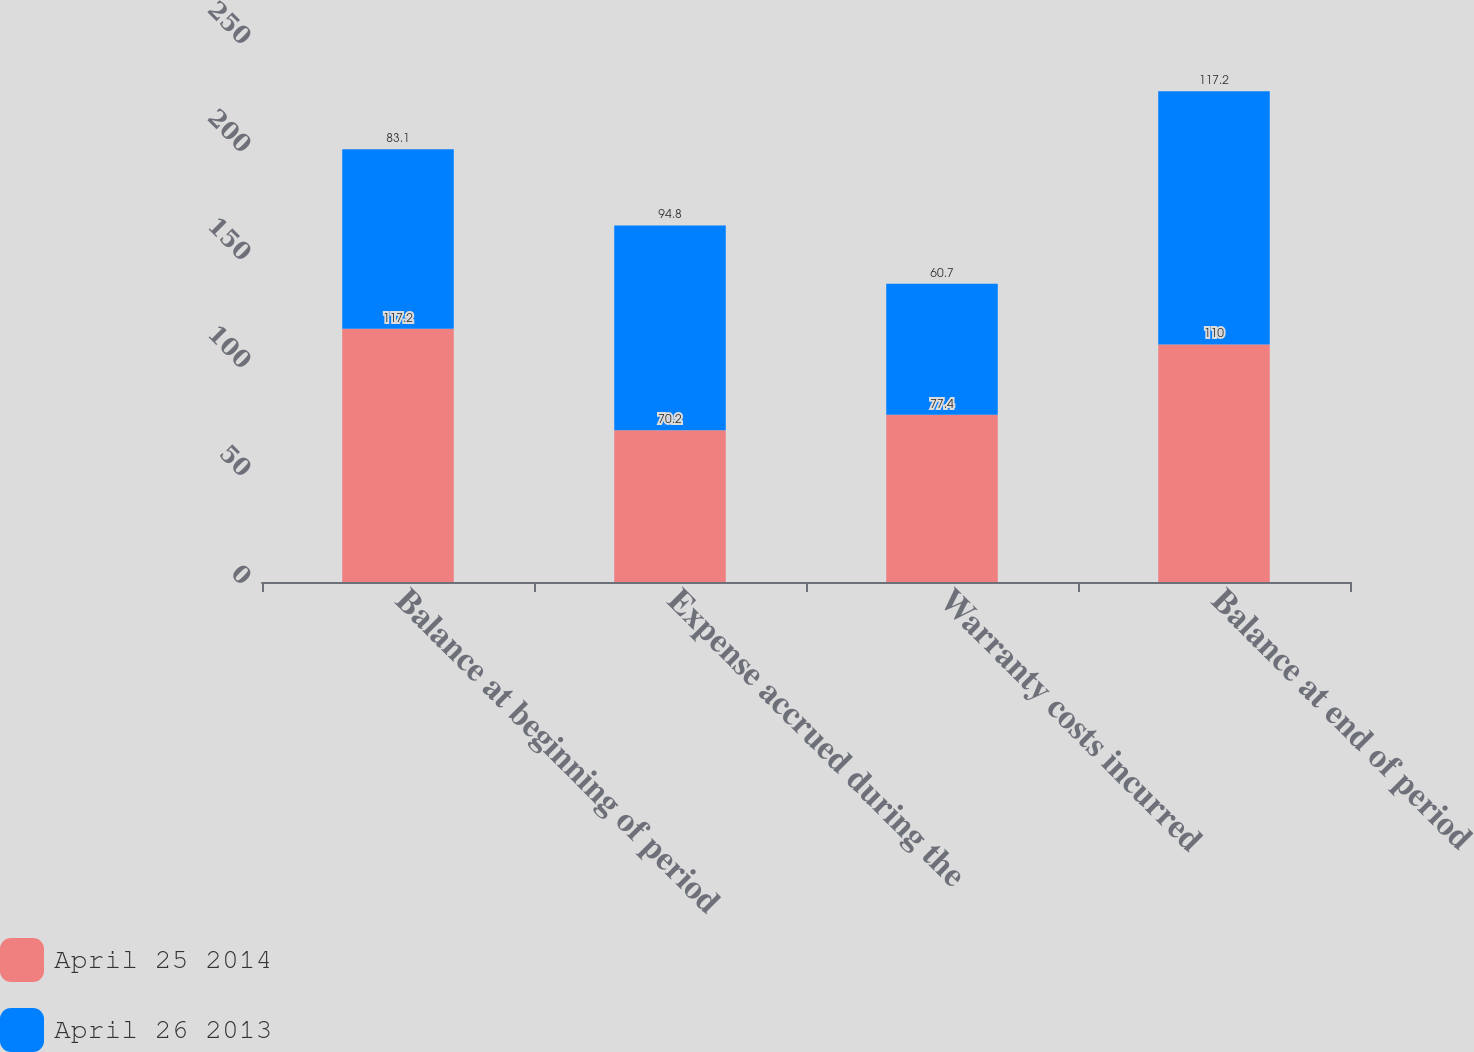<chart> <loc_0><loc_0><loc_500><loc_500><stacked_bar_chart><ecel><fcel>Balance at beginning of period<fcel>Expense accrued during the<fcel>Warranty costs incurred<fcel>Balance at end of period<nl><fcel>April 25 2014<fcel>117.2<fcel>70.2<fcel>77.4<fcel>110<nl><fcel>April 26 2013<fcel>83.1<fcel>94.8<fcel>60.7<fcel>117.2<nl></chart> 